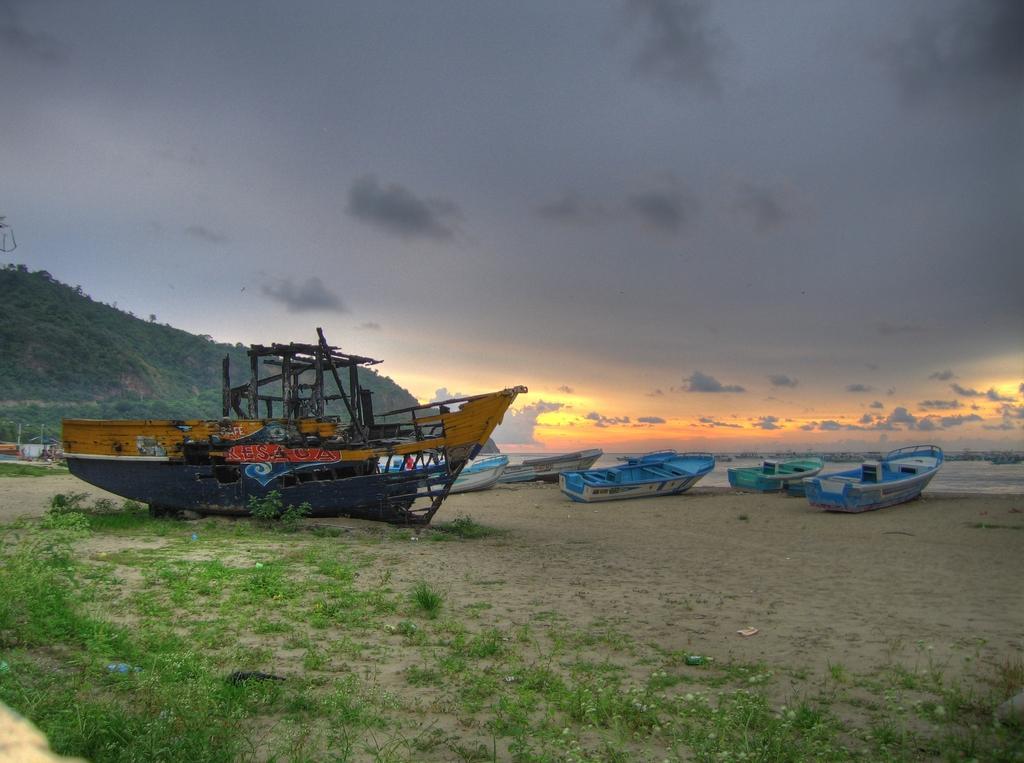Can you describe this image briefly? We can see grass and boats. In the background we can see hill,trees,water and sky. 